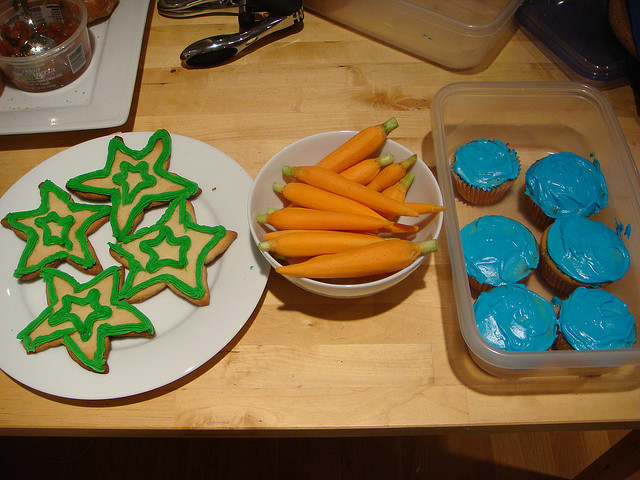<image>What letters are written on the cupcakes? There are no letters written on the cupcakes. What letters are written on the cupcakes? I am not sure what letters are written on the cupcakes. It seems like there are no letters or it is not visible. 